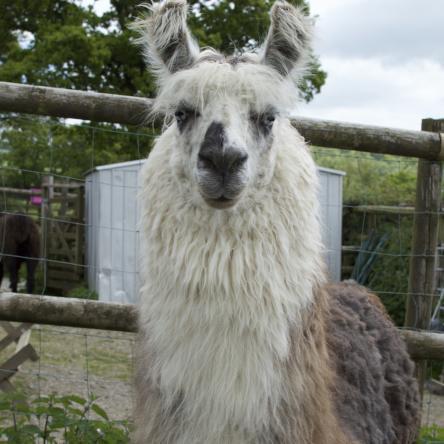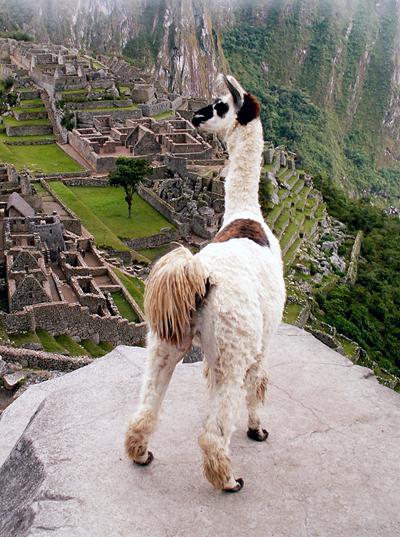The first image is the image on the left, the second image is the image on the right. For the images shown, is this caption "There are two llamas in one of the images." true? Answer yes or no. No. The first image is the image on the left, the second image is the image on the right. For the images shown, is this caption "The left image contains at least three llamas standing in a row and gazing in the same direction." true? Answer yes or no. No. 